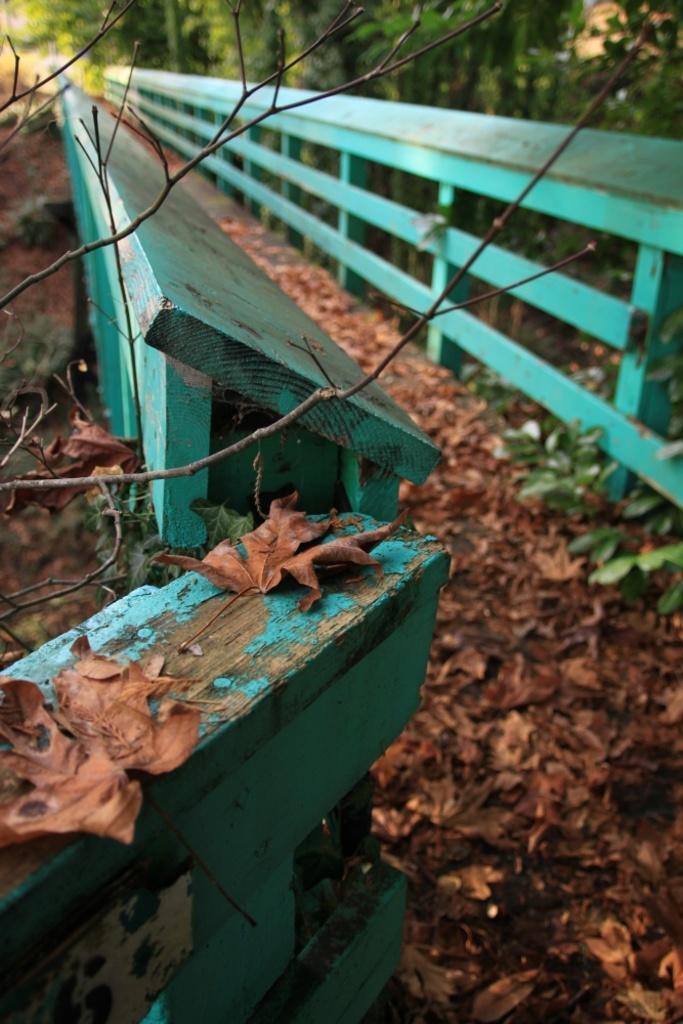Could you give a brief overview of what you see in this image? This image is clicked outside. In the front, there is a wooden bench. At the bottom, there are brown leaves. In the background, there are trees. 